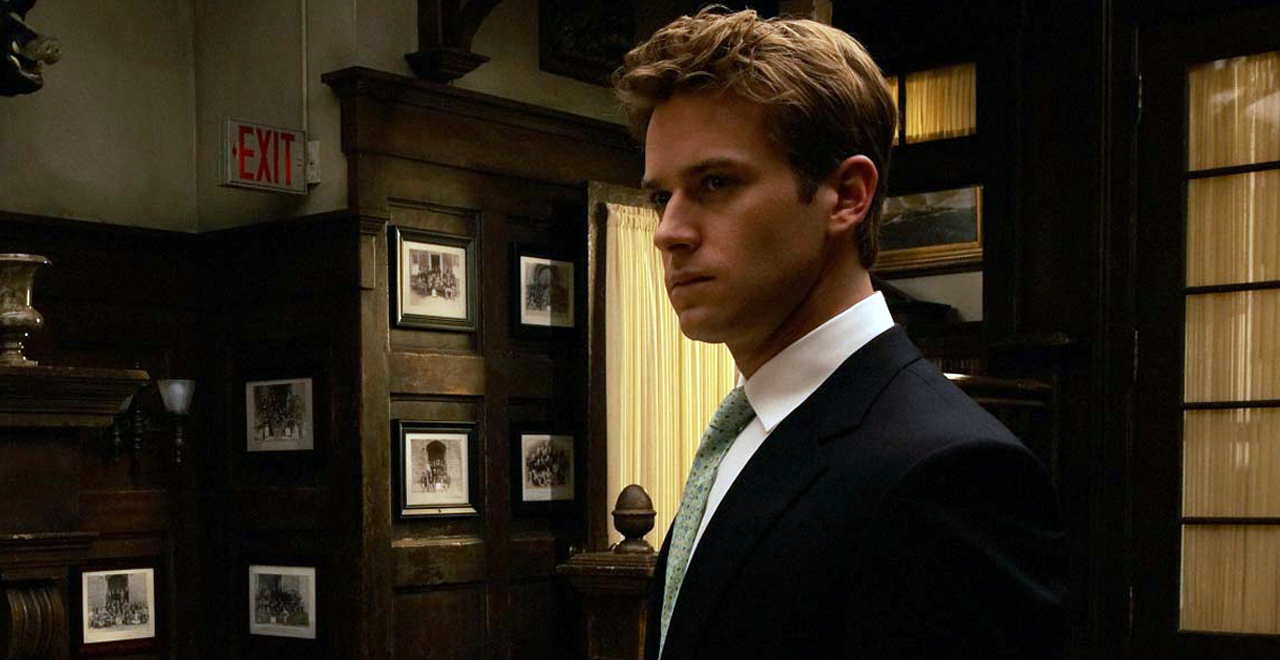Describe the significance of the setting in which the character is placed. The setting, with its dark wood paneling and shelves filled with books, creates an ambiance of old-world sophistication and intellectualism. This backdrop could signify that the character is in a place of learning or decision-making, such as a private study or library, suggesting themes of knowledge, power, or introspection. 